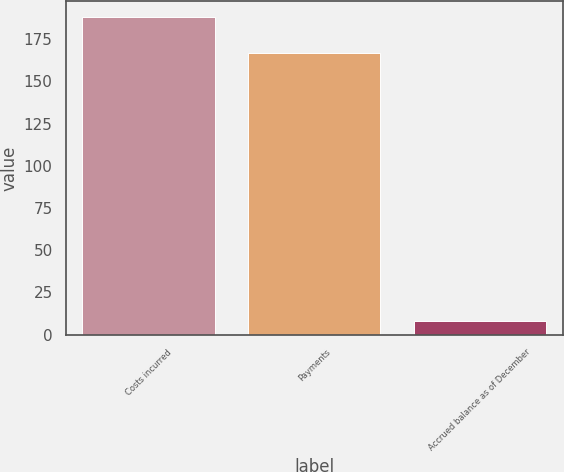Convert chart. <chart><loc_0><loc_0><loc_500><loc_500><bar_chart><fcel>Costs incurred<fcel>Payments<fcel>Accrued balance as of December<nl><fcel>188<fcel>167<fcel>8<nl></chart> 